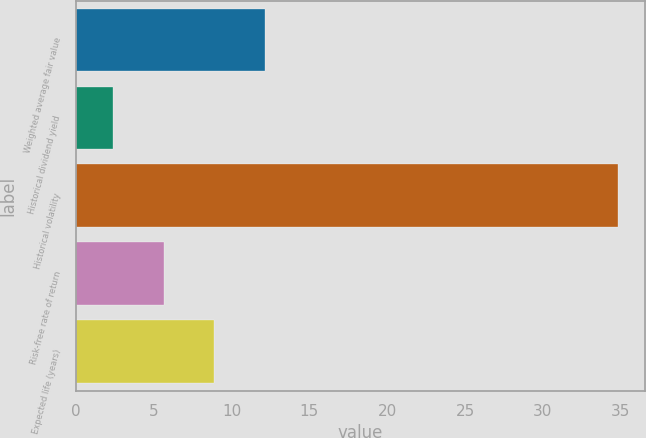Convert chart to OTSL. <chart><loc_0><loc_0><loc_500><loc_500><bar_chart><fcel>Weighted average fair value<fcel>Historical dividend yield<fcel>Historical volatility<fcel>Risk-free rate of return<fcel>Expected life (years)<nl><fcel>12.12<fcel>2.4<fcel>34.8<fcel>5.64<fcel>8.88<nl></chart> 